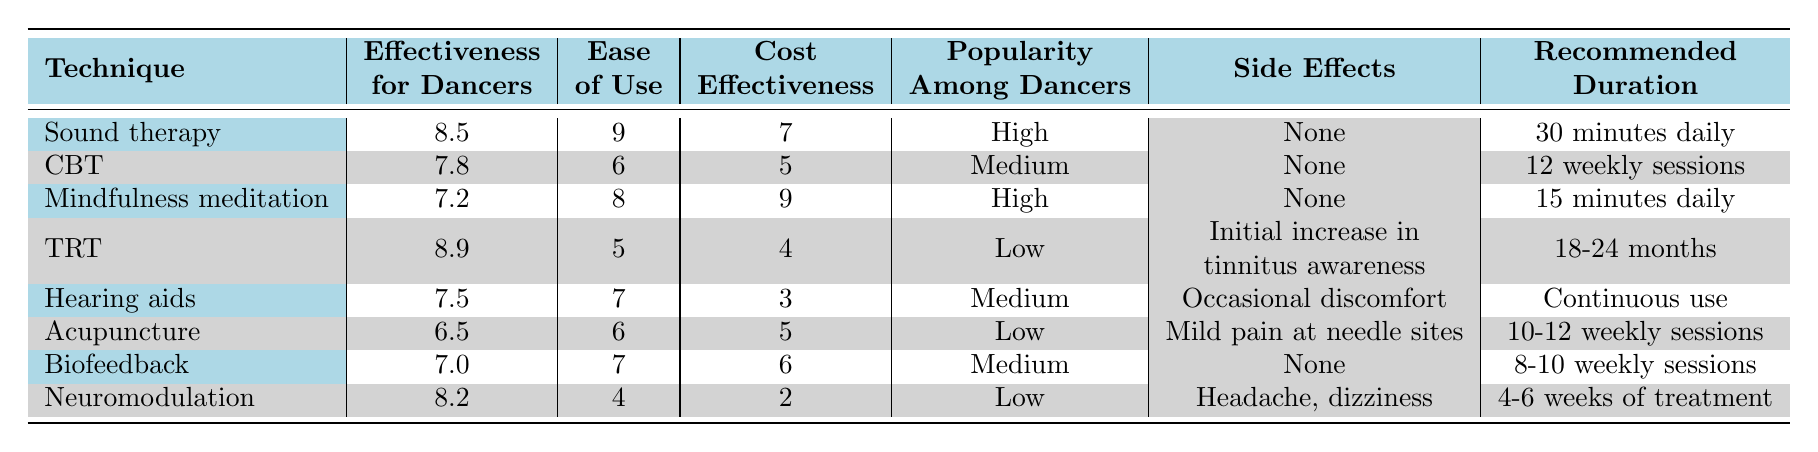What is the effectiveness score for Sound therapy? The table shows the effectiveness score for Sound therapy listed in the second column, which is 8.5.
Answer: 8.5 Which tinnitus management technique has the highest effectiveness for dancers? By comparing the effectiveness scores, Tinnitus Retraining Therapy (TRT) has the highest score of 8.9.
Answer: Tinnitus Retraining Therapy (TRT) How many techniques have high popularity among dancers? There are two techniques, Sound therapy and Mindfulness meditation, that are marked as having high popularity among dancers.
Answer: 2 What is the ease of use score for Neuromodulation? The table indicates that the ease of use score for Neuromodulation is 4, listed in the third column.
Answer: 4 Which technique has the longest recommended duration? Tinnitus Retraining Therapy (TRT) is listed with a recommended duration of 18-24 months, which is the longest compared to other techniques.
Answer: Tinnitus Retraining Therapy (TRT) What is the average effectiveness score of the techniques listed? The total effectiveness score is 8.5 + 7.8 + 7.2 + 8.9 + 7.5 + 6.5 + 7.0 + 8.2 = 63.6, and there are 8 techniques, so the average is 63.6/8 = 7.95.
Answer: 7.95 Are there any techniques with side effects? Yes, Tinnitus Retraining Therapy (TRT), Hearing aids, and Neuromodulation have listed side effects.
Answer: Yes Which technique has the best cost-effectiveness score? Mindfulness meditation has the highest cost-effectiveness score of 9, as seen in the fifth column of the table.
Answer: Mindfulness meditation How does the effectiveness of Hearing aids compare to that of Cognitive Behavioral Therapy (CBT)? Hearing aids have an effectiveness score of 7.5, while CBT has a score of 7.8. Since 7.5 is less than 7.8, Hearing aids are less effective than CBT.
Answer: Hearing aids are less effective Which technique has the lowest popularity among dancers? The table states that both Acupuncture and Neuromodulation have low popularity.
Answer: Acupuncture and Neuromodulation 